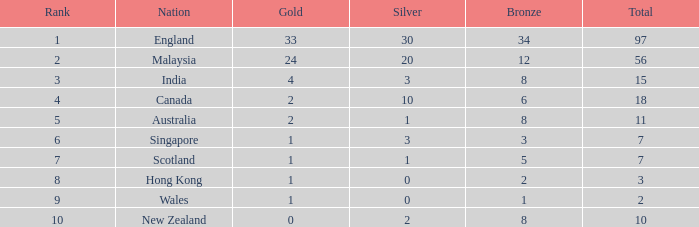For a team with fewer than 2 silver medals, more than 7 total medals, and less than 8 bronze medals, what is the maximum number of gold medals achieved? None. 